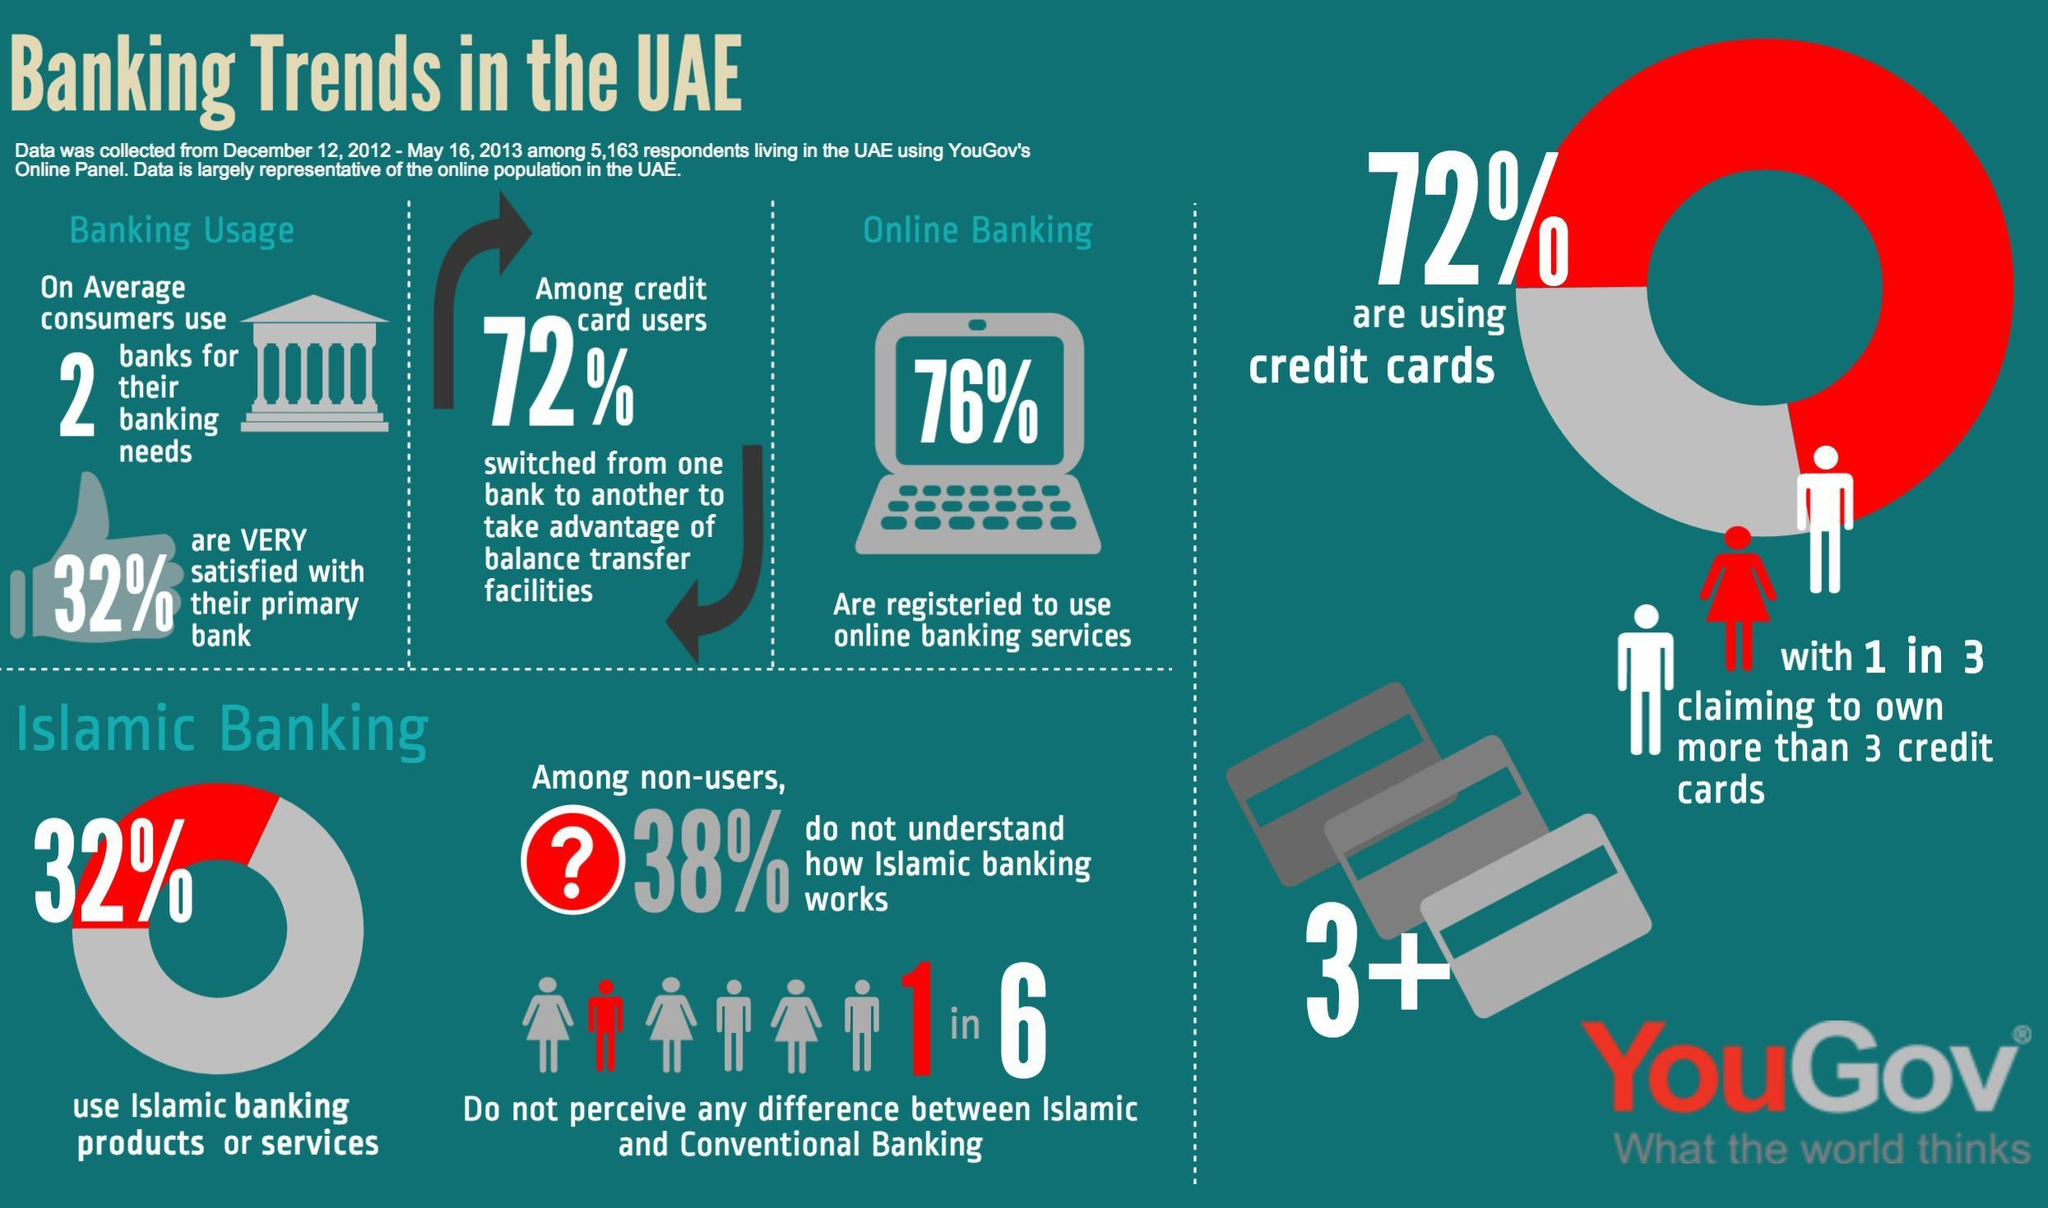What percentage of respondents living in UAE use online banking services according to the survey?
Answer the question with a short phrase. 76% What percentage of respondents living in UAE are not using credit cards  according to the survey? 28% What percentage of respondents living in UAE do not use Islamic banking products or services according to the survey? 68% 